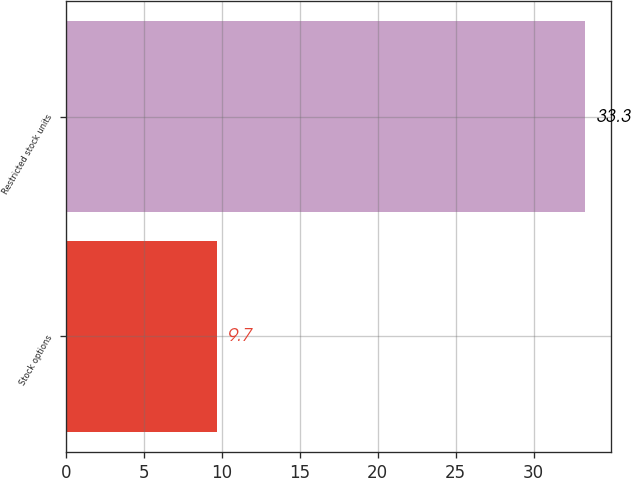<chart> <loc_0><loc_0><loc_500><loc_500><bar_chart><fcel>Stock options<fcel>Restricted stock units<nl><fcel>9.7<fcel>33.3<nl></chart> 